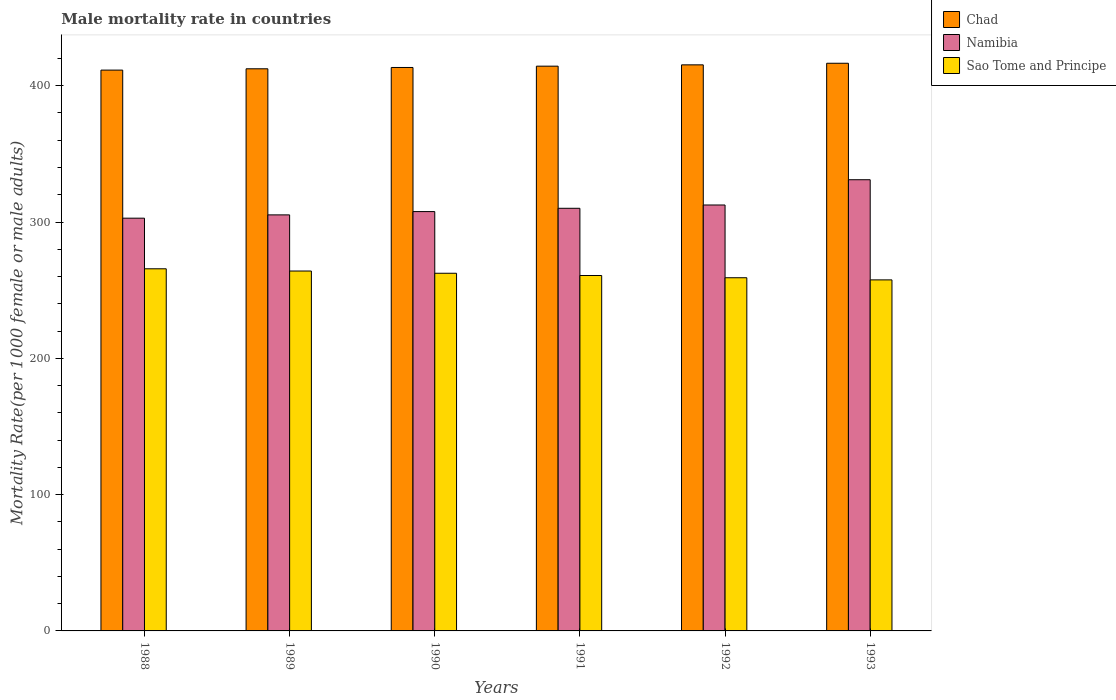How many groups of bars are there?
Your answer should be very brief. 6. Are the number of bars per tick equal to the number of legend labels?
Your response must be concise. Yes. Are the number of bars on each tick of the X-axis equal?
Offer a very short reply. Yes. How many bars are there on the 4th tick from the left?
Offer a terse response. 3. How many bars are there on the 3rd tick from the right?
Offer a very short reply. 3. What is the male mortality rate in Chad in 1993?
Your answer should be very brief. 416.46. Across all years, what is the maximum male mortality rate in Chad?
Provide a succinct answer. 416.46. Across all years, what is the minimum male mortality rate in Namibia?
Your answer should be compact. 302.8. In which year was the male mortality rate in Sao Tome and Principe maximum?
Provide a succinct answer. 1988. In which year was the male mortality rate in Sao Tome and Principe minimum?
Your response must be concise. 1993. What is the total male mortality rate in Namibia in the graph?
Your response must be concise. 1869.23. What is the difference between the male mortality rate in Chad in 1989 and that in 1991?
Give a very brief answer. -1.92. What is the difference between the male mortality rate in Chad in 1989 and the male mortality rate in Namibia in 1991?
Provide a succinct answer. 102.34. What is the average male mortality rate in Sao Tome and Principe per year?
Your answer should be compact. 261.58. In the year 1990, what is the difference between the male mortality rate in Chad and male mortality rate in Namibia?
Ensure brevity in your answer.  105.72. In how many years, is the male mortality rate in Namibia greater than 120?
Your response must be concise. 6. What is the ratio of the male mortality rate in Sao Tome and Principe in 1989 to that in 1990?
Provide a short and direct response. 1.01. What is the difference between the highest and the second highest male mortality rate in Chad?
Provide a short and direct response. 1.17. What is the difference between the highest and the lowest male mortality rate in Namibia?
Provide a short and direct response. 28.22. In how many years, is the male mortality rate in Namibia greater than the average male mortality rate in Namibia taken over all years?
Your response must be concise. 2. What does the 3rd bar from the left in 1988 represents?
Ensure brevity in your answer.  Sao Tome and Principe. What does the 1st bar from the right in 1993 represents?
Give a very brief answer. Sao Tome and Principe. How many bars are there?
Provide a succinct answer. 18. Are all the bars in the graph horizontal?
Ensure brevity in your answer.  No. What is the difference between two consecutive major ticks on the Y-axis?
Ensure brevity in your answer.  100. Are the values on the major ticks of Y-axis written in scientific E-notation?
Ensure brevity in your answer.  No. Where does the legend appear in the graph?
Provide a succinct answer. Top right. How are the legend labels stacked?
Make the answer very short. Vertical. What is the title of the graph?
Your response must be concise. Male mortality rate in countries. Does "Paraguay" appear as one of the legend labels in the graph?
Provide a succinct answer. No. What is the label or title of the Y-axis?
Give a very brief answer. Mortality Rate(per 1000 female or male adults). What is the Mortality Rate(per 1000 female or male adults) in Chad in 1988?
Ensure brevity in your answer.  411.44. What is the Mortality Rate(per 1000 female or male adults) of Namibia in 1988?
Offer a very short reply. 302.8. What is the Mortality Rate(per 1000 female or male adults) in Sao Tome and Principe in 1988?
Offer a terse response. 265.67. What is the Mortality Rate(per 1000 female or male adults) in Chad in 1989?
Provide a short and direct response. 412.4. What is the Mortality Rate(per 1000 female or male adults) of Namibia in 1989?
Your answer should be very brief. 305.22. What is the Mortality Rate(per 1000 female or male adults) in Sao Tome and Principe in 1989?
Give a very brief answer. 264.03. What is the Mortality Rate(per 1000 female or male adults) of Chad in 1990?
Provide a succinct answer. 413.36. What is the Mortality Rate(per 1000 female or male adults) in Namibia in 1990?
Your response must be concise. 307.64. What is the Mortality Rate(per 1000 female or male adults) of Sao Tome and Principe in 1990?
Offer a terse response. 262.39. What is the Mortality Rate(per 1000 female or male adults) in Chad in 1991?
Provide a short and direct response. 414.32. What is the Mortality Rate(per 1000 female or male adults) in Namibia in 1991?
Make the answer very short. 310.06. What is the Mortality Rate(per 1000 female or male adults) in Sao Tome and Principe in 1991?
Provide a succinct answer. 260.75. What is the Mortality Rate(per 1000 female or male adults) in Chad in 1992?
Provide a short and direct response. 415.29. What is the Mortality Rate(per 1000 female or male adults) in Namibia in 1992?
Your response must be concise. 312.48. What is the Mortality Rate(per 1000 female or male adults) of Sao Tome and Principe in 1992?
Provide a succinct answer. 259.11. What is the Mortality Rate(per 1000 female or male adults) of Chad in 1993?
Your answer should be compact. 416.46. What is the Mortality Rate(per 1000 female or male adults) in Namibia in 1993?
Make the answer very short. 331.02. What is the Mortality Rate(per 1000 female or male adults) in Sao Tome and Principe in 1993?
Provide a short and direct response. 257.53. Across all years, what is the maximum Mortality Rate(per 1000 female or male adults) of Chad?
Make the answer very short. 416.46. Across all years, what is the maximum Mortality Rate(per 1000 female or male adults) in Namibia?
Offer a terse response. 331.02. Across all years, what is the maximum Mortality Rate(per 1000 female or male adults) of Sao Tome and Principe?
Keep it short and to the point. 265.67. Across all years, what is the minimum Mortality Rate(per 1000 female or male adults) of Chad?
Provide a short and direct response. 411.44. Across all years, what is the minimum Mortality Rate(per 1000 female or male adults) of Namibia?
Provide a succinct answer. 302.8. Across all years, what is the minimum Mortality Rate(per 1000 female or male adults) of Sao Tome and Principe?
Give a very brief answer. 257.53. What is the total Mortality Rate(per 1000 female or male adults) of Chad in the graph?
Keep it short and to the point. 2483.27. What is the total Mortality Rate(per 1000 female or male adults) in Namibia in the graph?
Provide a succinct answer. 1869.23. What is the total Mortality Rate(per 1000 female or male adults) of Sao Tome and Principe in the graph?
Your answer should be compact. 1569.48. What is the difference between the Mortality Rate(per 1000 female or male adults) in Chad in 1988 and that in 1989?
Your response must be concise. -0.96. What is the difference between the Mortality Rate(per 1000 female or male adults) of Namibia in 1988 and that in 1989?
Provide a succinct answer. -2.42. What is the difference between the Mortality Rate(per 1000 female or male adults) of Sao Tome and Principe in 1988 and that in 1989?
Your answer should be compact. 1.64. What is the difference between the Mortality Rate(per 1000 female or male adults) in Chad in 1988 and that in 1990?
Make the answer very short. -1.92. What is the difference between the Mortality Rate(per 1000 female or male adults) of Namibia in 1988 and that in 1990?
Provide a succinct answer. -4.84. What is the difference between the Mortality Rate(per 1000 female or male adults) in Sao Tome and Principe in 1988 and that in 1990?
Offer a terse response. 3.28. What is the difference between the Mortality Rate(per 1000 female or male adults) of Chad in 1988 and that in 1991?
Make the answer very short. -2.88. What is the difference between the Mortality Rate(per 1000 female or male adults) of Namibia in 1988 and that in 1991?
Provide a succinct answer. -7.26. What is the difference between the Mortality Rate(per 1000 female or male adults) in Sao Tome and Principe in 1988 and that in 1991?
Ensure brevity in your answer.  4.92. What is the difference between the Mortality Rate(per 1000 female or male adults) of Chad in 1988 and that in 1992?
Offer a terse response. -3.85. What is the difference between the Mortality Rate(per 1000 female or male adults) of Namibia in 1988 and that in 1992?
Offer a very short reply. -9.68. What is the difference between the Mortality Rate(per 1000 female or male adults) of Sao Tome and Principe in 1988 and that in 1992?
Your response must be concise. 6.56. What is the difference between the Mortality Rate(per 1000 female or male adults) of Chad in 1988 and that in 1993?
Your answer should be compact. -5.02. What is the difference between the Mortality Rate(per 1000 female or male adults) in Namibia in 1988 and that in 1993?
Give a very brief answer. -28.22. What is the difference between the Mortality Rate(per 1000 female or male adults) in Sao Tome and Principe in 1988 and that in 1993?
Ensure brevity in your answer.  8.14. What is the difference between the Mortality Rate(per 1000 female or male adults) of Chad in 1989 and that in 1990?
Provide a short and direct response. -0.96. What is the difference between the Mortality Rate(per 1000 female or male adults) in Namibia in 1989 and that in 1990?
Make the answer very short. -2.42. What is the difference between the Mortality Rate(per 1000 female or male adults) in Sao Tome and Principe in 1989 and that in 1990?
Provide a succinct answer. 1.64. What is the difference between the Mortality Rate(per 1000 female or male adults) in Chad in 1989 and that in 1991?
Offer a very short reply. -1.92. What is the difference between the Mortality Rate(per 1000 female or male adults) of Namibia in 1989 and that in 1991?
Keep it short and to the point. -4.84. What is the difference between the Mortality Rate(per 1000 female or male adults) in Sao Tome and Principe in 1989 and that in 1991?
Your response must be concise. 3.28. What is the difference between the Mortality Rate(per 1000 female or male adults) in Chad in 1989 and that in 1992?
Provide a short and direct response. -2.88. What is the difference between the Mortality Rate(per 1000 female or male adults) of Namibia in 1989 and that in 1992?
Give a very brief answer. -7.26. What is the difference between the Mortality Rate(per 1000 female or male adults) in Sao Tome and Principe in 1989 and that in 1992?
Ensure brevity in your answer.  4.92. What is the difference between the Mortality Rate(per 1000 female or male adults) of Chad in 1989 and that in 1993?
Make the answer very short. -4.06. What is the difference between the Mortality Rate(per 1000 female or male adults) of Namibia in 1989 and that in 1993?
Offer a very short reply. -25.8. What is the difference between the Mortality Rate(per 1000 female or male adults) of Sao Tome and Principe in 1989 and that in 1993?
Your answer should be compact. 6.5. What is the difference between the Mortality Rate(per 1000 female or male adults) of Chad in 1990 and that in 1991?
Offer a terse response. -0.96. What is the difference between the Mortality Rate(per 1000 female or male adults) in Namibia in 1990 and that in 1991?
Offer a very short reply. -2.42. What is the difference between the Mortality Rate(per 1000 female or male adults) in Sao Tome and Principe in 1990 and that in 1991?
Ensure brevity in your answer.  1.64. What is the difference between the Mortality Rate(per 1000 female or male adults) in Chad in 1990 and that in 1992?
Make the answer very short. -1.92. What is the difference between the Mortality Rate(per 1000 female or male adults) of Namibia in 1990 and that in 1992?
Provide a short and direct response. -4.84. What is the difference between the Mortality Rate(per 1000 female or male adults) of Sao Tome and Principe in 1990 and that in 1992?
Your answer should be very brief. 3.28. What is the difference between the Mortality Rate(per 1000 female or male adults) of Chad in 1990 and that in 1993?
Offer a very short reply. -3.1. What is the difference between the Mortality Rate(per 1000 female or male adults) of Namibia in 1990 and that in 1993?
Ensure brevity in your answer.  -23.38. What is the difference between the Mortality Rate(per 1000 female or male adults) in Sao Tome and Principe in 1990 and that in 1993?
Your answer should be compact. 4.86. What is the difference between the Mortality Rate(per 1000 female or male adults) of Chad in 1991 and that in 1992?
Ensure brevity in your answer.  -0.96. What is the difference between the Mortality Rate(per 1000 female or male adults) of Namibia in 1991 and that in 1992?
Make the answer very short. -2.42. What is the difference between the Mortality Rate(per 1000 female or male adults) in Sao Tome and Principe in 1991 and that in 1992?
Offer a very short reply. 1.64. What is the difference between the Mortality Rate(per 1000 female or male adults) in Chad in 1991 and that in 1993?
Provide a succinct answer. -2.13. What is the difference between the Mortality Rate(per 1000 female or male adults) of Namibia in 1991 and that in 1993?
Your answer should be compact. -20.95. What is the difference between the Mortality Rate(per 1000 female or male adults) of Sao Tome and Principe in 1991 and that in 1993?
Your answer should be compact. 3.22. What is the difference between the Mortality Rate(per 1000 female or male adults) in Chad in 1992 and that in 1993?
Offer a terse response. -1.17. What is the difference between the Mortality Rate(per 1000 female or male adults) of Namibia in 1992 and that in 1993?
Keep it short and to the point. -18.54. What is the difference between the Mortality Rate(per 1000 female or male adults) of Sao Tome and Principe in 1992 and that in 1993?
Give a very brief answer. 1.58. What is the difference between the Mortality Rate(per 1000 female or male adults) of Chad in 1988 and the Mortality Rate(per 1000 female or male adults) of Namibia in 1989?
Offer a terse response. 106.22. What is the difference between the Mortality Rate(per 1000 female or male adults) in Chad in 1988 and the Mortality Rate(per 1000 female or male adults) in Sao Tome and Principe in 1989?
Offer a terse response. 147.41. What is the difference between the Mortality Rate(per 1000 female or male adults) of Namibia in 1988 and the Mortality Rate(per 1000 female or male adults) of Sao Tome and Principe in 1989?
Offer a terse response. 38.77. What is the difference between the Mortality Rate(per 1000 female or male adults) of Chad in 1988 and the Mortality Rate(per 1000 female or male adults) of Namibia in 1990?
Provide a short and direct response. 103.8. What is the difference between the Mortality Rate(per 1000 female or male adults) of Chad in 1988 and the Mortality Rate(per 1000 female or male adults) of Sao Tome and Principe in 1990?
Offer a very short reply. 149.05. What is the difference between the Mortality Rate(per 1000 female or male adults) of Namibia in 1988 and the Mortality Rate(per 1000 female or male adults) of Sao Tome and Principe in 1990?
Your answer should be very brief. 40.41. What is the difference between the Mortality Rate(per 1000 female or male adults) in Chad in 1988 and the Mortality Rate(per 1000 female or male adults) in Namibia in 1991?
Provide a succinct answer. 101.38. What is the difference between the Mortality Rate(per 1000 female or male adults) in Chad in 1988 and the Mortality Rate(per 1000 female or male adults) in Sao Tome and Principe in 1991?
Provide a short and direct response. 150.69. What is the difference between the Mortality Rate(per 1000 female or male adults) of Namibia in 1988 and the Mortality Rate(per 1000 female or male adults) of Sao Tome and Principe in 1991?
Offer a terse response. 42.05. What is the difference between the Mortality Rate(per 1000 female or male adults) of Chad in 1988 and the Mortality Rate(per 1000 female or male adults) of Namibia in 1992?
Offer a very short reply. 98.96. What is the difference between the Mortality Rate(per 1000 female or male adults) in Chad in 1988 and the Mortality Rate(per 1000 female or male adults) in Sao Tome and Principe in 1992?
Your answer should be compact. 152.33. What is the difference between the Mortality Rate(per 1000 female or male adults) of Namibia in 1988 and the Mortality Rate(per 1000 female or male adults) of Sao Tome and Principe in 1992?
Offer a terse response. 43.69. What is the difference between the Mortality Rate(per 1000 female or male adults) in Chad in 1988 and the Mortality Rate(per 1000 female or male adults) in Namibia in 1993?
Offer a terse response. 80.42. What is the difference between the Mortality Rate(per 1000 female or male adults) in Chad in 1988 and the Mortality Rate(per 1000 female or male adults) in Sao Tome and Principe in 1993?
Ensure brevity in your answer.  153.91. What is the difference between the Mortality Rate(per 1000 female or male adults) of Namibia in 1988 and the Mortality Rate(per 1000 female or male adults) of Sao Tome and Principe in 1993?
Offer a very short reply. 45.27. What is the difference between the Mortality Rate(per 1000 female or male adults) in Chad in 1989 and the Mortality Rate(per 1000 female or male adults) in Namibia in 1990?
Provide a succinct answer. 104.76. What is the difference between the Mortality Rate(per 1000 female or male adults) in Chad in 1989 and the Mortality Rate(per 1000 female or male adults) in Sao Tome and Principe in 1990?
Offer a terse response. 150.01. What is the difference between the Mortality Rate(per 1000 female or male adults) of Namibia in 1989 and the Mortality Rate(per 1000 female or male adults) of Sao Tome and Principe in 1990?
Your answer should be very brief. 42.83. What is the difference between the Mortality Rate(per 1000 female or male adults) in Chad in 1989 and the Mortality Rate(per 1000 female or male adults) in Namibia in 1991?
Keep it short and to the point. 102.34. What is the difference between the Mortality Rate(per 1000 female or male adults) in Chad in 1989 and the Mortality Rate(per 1000 female or male adults) in Sao Tome and Principe in 1991?
Ensure brevity in your answer.  151.65. What is the difference between the Mortality Rate(per 1000 female or male adults) of Namibia in 1989 and the Mortality Rate(per 1000 female or male adults) of Sao Tome and Principe in 1991?
Offer a terse response. 44.47. What is the difference between the Mortality Rate(per 1000 female or male adults) in Chad in 1989 and the Mortality Rate(per 1000 female or male adults) in Namibia in 1992?
Keep it short and to the point. 99.92. What is the difference between the Mortality Rate(per 1000 female or male adults) in Chad in 1989 and the Mortality Rate(per 1000 female or male adults) in Sao Tome and Principe in 1992?
Give a very brief answer. 153.29. What is the difference between the Mortality Rate(per 1000 female or male adults) in Namibia in 1989 and the Mortality Rate(per 1000 female or male adults) in Sao Tome and Principe in 1992?
Your answer should be compact. 46.11. What is the difference between the Mortality Rate(per 1000 female or male adults) in Chad in 1989 and the Mortality Rate(per 1000 female or male adults) in Namibia in 1993?
Ensure brevity in your answer.  81.38. What is the difference between the Mortality Rate(per 1000 female or male adults) of Chad in 1989 and the Mortality Rate(per 1000 female or male adults) of Sao Tome and Principe in 1993?
Give a very brief answer. 154.87. What is the difference between the Mortality Rate(per 1000 female or male adults) of Namibia in 1989 and the Mortality Rate(per 1000 female or male adults) of Sao Tome and Principe in 1993?
Offer a terse response. 47.69. What is the difference between the Mortality Rate(per 1000 female or male adults) in Chad in 1990 and the Mortality Rate(per 1000 female or male adults) in Namibia in 1991?
Your response must be concise. 103.3. What is the difference between the Mortality Rate(per 1000 female or male adults) of Chad in 1990 and the Mortality Rate(per 1000 female or male adults) of Sao Tome and Principe in 1991?
Your answer should be very brief. 152.61. What is the difference between the Mortality Rate(per 1000 female or male adults) in Namibia in 1990 and the Mortality Rate(per 1000 female or male adults) in Sao Tome and Principe in 1991?
Give a very brief answer. 46.89. What is the difference between the Mortality Rate(per 1000 female or male adults) in Chad in 1990 and the Mortality Rate(per 1000 female or male adults) in Namibia in 1992?
Make the answer very short. 100.88. What is the difference between the Mortality Rate(per 1000 female or male adults) in Chad in 1990 and the Mortality Rate(per 1000 female or male adults) in Sao Tome and Principe in 1992?
Your response must be concise. 154.25. What is the difference between the Mortality Rate(per 1000 female or male adults) of Namibia in 1990 and the Mortality Rate(per 1000 female or male adults) of Sao Tome and Principe in 1992?
Offer a terse response. 48.53. What is the difference between the Mortality Rate(per 1000 female or male adults) in Chad in 1990 and the Mortality Rate(per 1000 female or male adults) in Namibia in 1993?
Your answer should be very brief. 82.34. What is the difference between the Mortality Rate(per 1000 female or male adults) in Chad in 1990 and the Mortality Rate(per 1000 female or male adults) in Sao Tome and Principe in 1993?
Provide a succinct answer. 155.83. What is the difference between the Mortality Rate(per 1000 female or male adults) of Namibia in 1990 and the Mortality Rate(per 1000 female or male adults) of Sao Tome and Principe in 1993?
Your response must be concise. 50.11. What is the difference between the Mortality Rate(per 1000 female or male adults) of Chad in 1991 and the Mortality Rate(per 1000 female or male adults) of Namibia in 1992?
Your answer should be compact. 101.84. What is the difference between the Mortality Rate(per 1000 female or male adults) in Chad in 1991 and the Mortality Rate(per 1000 female or male adults) in Sao Tome and Principe in 1992?
Your answer should be compact. 155.21. What is the difference between the Mortality Rate(per 1000 female or male adults) in Namibia in 1991 and the Mortality Rate(per 1000 female or male adults) in Sao Tome and Principe in 1992?
Your answer should be compact. 50.95. What is the difference between the Mortality Rate(per 1000 female or male adults) in Chad in 1991 and the Mortality Rate(per 1000 female or male adults) in Namibia in 1993?
Make the answer very short. 83.31. What is the difference between the Mortality Rate(per 1000 female or male adults) of Chad in 1991 and the Mortality Rate(per 1000 female or male adults) of Sao Tome and Principe in 1993?
Provide a short and direct response. 156.79. What is the difference between the Mortality Rate(per 1000 female or male adults) in Namibia in 1991 and the Mortality Rate(per 1000 female or male adults) in Sao Tome and Principe in 1993?
Your response must be concise. 52.53. What is the difference between the Mortality Rate(per 1000 female or male adults) of Chad in 1992 and the Mortality Rate(per 1000 female or male adults) of Namibia in 1993?
Make the answer very short. 84.27. What is the difference between the Mortality Rate(per 1000 female or male adults) in Chad in 1992 and the Mortality Rate(per 1000 female or male adults) in Sao Tome and Principe in 1993?
Keep it short and to the point. 157.76. What is the difference between the Mortality Rate(per 1000 female or male adults) of Namibia in 1992 and the Mortality Rate(per 1000 female or male adults) of Sao Tome and Principe in 1993?
Your answer should be very brief. 54.95. What is the average Mortality Rate(per 1000 female or male adults) of Chad per year?
Your answer should be compact. 413.88. What is the average Mortality Rate(per 1000 female or male adults) in Namibia per year?
Your response must be concise. 311.54. What is the average Mortality Rate(per 1000 female or male adults) of Sao Tome and Principe per year?
Offer a terse response. 261.58. In the year 1988, what is the difference between the Mortality Rate(per 1000 female or male adults) in Chad and Mortality Rate(per 1000 female or male adults) in Namibia?
Provide a short and direct response. 108.64. In the year 1988, what is the difference between the Mortality Rate(per 1000 female or male adults) of Chad and Mortality Rate(per 1000 female or male adults) of Sao Tome and Principe?
Make the answer very short. 145.77. In the year 1988, what is the difference between the Mortality Rate(per 1000 female or male adults) of Namibia and Mortality Rate(per 1000 female or male adults) of Sao Tome and Principe?
Keep it short and to the point. 37.13. In the year 1989, what is the difference between the Mortality Rate(per 1000 female or male adults) in Chad and Mortality Rate(per 1000 female or male adults) in Namibia?
Provide a succinct answer. 107.18. In the year 1989, what is the difference between the Mortality Rate(per 1000 female or male adults) of Chad and Mortality Rate(per 1000 female or male adults) of Sao Tome and Principe?
Keep it short and to the point. 148.37. In the year 1989, what is the difference between the Mortality Rate(per 1000 female or male adults) in Namibia and Mortality Rate(per 1000 female or male adults) in Sao Tome and Principe?
Provide a short and direct response. 41.19. In the year 1990, what is the difference between the Mortality Rate(per 1000 female or male adults) in Chad and Mortality Rate(per 1000 female or male adults) in Namibia?
Keep it short and to the point. 105.72. In the year 1990, what is the difference between the Mortality Rate(per 1000 female or male adults) of Chad and Mortality Rate(per 1000 female or male adults) of Sao Tome and Principe?
Offer a very short reply. 150.97. In the year 1990, what is the difference between the Mortality Rate(per 1000 female or male adults) in Namibia and Mortality Rate(per 1000 female or male adults) in Sao Tome and Principe?
Offer a terse response. 45.25. In the year 1991, what is the difference between the Mortality Rate(per 1000 female or male adults) of Chad and Mortality Rate(per 1000 female or male adults) of Namibia?
Offer a terse response. 104.26. In the year 1991, what is the difference between the Mortality Rate(per 1000 female or male adults) in Chad and Mortality Rate(per 1000 female or male adults) in Sao Tome and Principe?
Provide a succinct answer. 153.57. In the year 1991, what is the difference between the Mortality Rate(per 1000 female or male adults) of Namibia and Mortality Rate(per 1000 female or male adults) of Sao Tome and Principe?
Offer a terse response. 49.31. In the year 1992, what is the difference between the Mortality Rate(per 1000 female or male adults) in Chad and Mortality Rate(per 1000 female or male adults) in Namibia?
Make the answer very short. 102.8. In the year 1992, what is the difference between the Mortality Rate(per 1000 female or male adults) of Chad and Mortality Rate(per 1000 female or male adults) of Sao Tome and Principe?
Offer a very short reply. 156.18. In the year 1992, what is the difference between the Mortality Rate(per 1000 female or male adults) in Namibia and Mortality Rate(per 1000 female or male adults) in Sao Tome and Principe?
Provide a short and direct response. 53.37. In the year 1993, what is the difference between the Mortality Rate(per 1000 female or male adults) of Chad and Mortality Rate(per 1000 female or male adults) of Namibia?
Your answer should be very brief. 85.44. In the year 1993, what is the difference between the Mortality Rate(per 1000 female or male adults) in Chad and Mortality Rate(per 1000 female or male adults) in Sao Tome and Principe?
Give a very brief answer. 158.93. In the year 1993, what is the difference between the Mortality Rate(per 1000 female or male adults) in Namibia and Mortality Rate(per 1000 female or male adults) in Sao Tome and Principe?
Give a very brief answer. 73.49. What is the ratio of the Mortality Rate(per 1000 female or male adults) of Namibia in 1988 to that in 1990?
Your answer should be compact. 0.98. What is the ratio of the Mortality Rate(per 1000 female or male adults) of Sao Tome and Principe in 1988 to that in 1990?
Offer a very short reply. 1.01. What is the ratio of the Mortality Rate(per 1000 female or male adults) in Namibia in 1988 to that in 1991?
Your answer should be very brief. 0.98. What is the ratio of the Mortality Rate(per 1000 female or male adults) of Sao Tome and Principe in 1988 to that in 1991?
Your response must be concise. 1.02. What is the ratio of the Mortality Rate(per 1000 female or male adults) in Chad in 1988 to that in 1992?
Offer a terse response. 0.99. What is the ratio of the Mortality Rate(per 1000 female or male adults) in Sao Tome and Principe in 1988 to that in 1992?
Your answer should be very brief. 1.03. What is the ratio of the Mortality Rate(per 1000 female or male adults) in Chad in 1988 to that in 1993?
Provide a short and direct response. 0.99. What is the ratio of the Mortality Rate(per 1000 female or male adults) of Namibia in 1988 to that in 1993?
Make the answer very short. 0.91. What is the ratio of the Mortality Rate(per 1000 female or male adults) of Sao Tome and Principe in 1988 to that in 1993?
Your response must be concise. 1.03. What is the ratio of the Mortality Rate(per 1000 female or male adults) of Chad in 1989 to that in 1990?
Your response must be concise. 1. What is the ratio of the Mortality Rate(per 1000 female or male adults) in Namibia in 1989 to that in 1990?
Your response must be concise. 0.99. What is the ratio of the Mortality Rate(per 1000 female or male adults) in Sao Tome and Principe in 1989 to that in 1990?
Your response must be concise. 1.01. What is the ratio of the Mortality Rate(per 1000 female or male adults) of Chad in 1989 to that in 1991?
Offer a very short reply. 1. What is the ratio of the Mortality Rate(per 1000 female or male adults) of Namibia in 1989 to that in 1991?
Provide a short and direct response. 0.98. What is the ratio of the Mortality Rate(per 1000 female or male adults) of Sao Tome and Principe in 1989 to that in 1991?
Ensure brevity in your answer.  1.01. What is the ratio of the Mortality Rate(per 1000 female or male adults) in Chad in 1989 to that in 1992?
Offer a terse response. 0.99. What is the ratio of the Mortality Rate(per 1000 female or male adults) of Namibia in 1989 to that in 1992?
Offer a very short reply. 0.98. What is the ratio of the Mortality Rate(per 1000 female or male adults) of Sao Tome and Principe in 1989 to that in 1992?
Provide a short and direct response. 1.02. What is the ratio of the Mortality Rate(per 1000 female or male adults) in Chad in 1989 to that in 1993?
Your answer should be very brief. 0.99. What is the ratio of the Mortality Rate(per 1000 female or male adults) of Namibia in 1989 to that in 1993?
Ensure brevity in your answer.  0.92. What is the ratio of the Mortality Rate(per 1000 female or male adults) of Sao Tome and Principe in 1989 to that in 1993?
Make the answer very short. 1.03. What is the ratio of the Mortality Rate(per 1000 female or male adults) of Chad in 1990 to that in 1992?
Provide a succinct answer. 1. What is the ratio of the Mortality Rate(per 1000 female or male adults) in Namibia in 1990 to that in 1992?
Give a very brief answer. 0.98. What is the ratio of the Mortality Rate(per 1000 female or male adults) in Sao Tome and Principe in 1990 to that in 1992?
Ensure brevity in your answer.  1.01. What is the ratio of the Mortality Rate(per 1000 female or male adults) of Namibia in 1990 to that in 1993?
Your response must be concise. 0.93. What is the ratio of the Mortality Rate(per 1000 female or male adults) in Sao Tome and Principe in 1990 to that in 1993?
Provide a short and direct response. 1.02. What is the ratio of the Mortality Rate(per 1000 female or male adults) of Namibia in 1991 to that in 1992?
Provide a succinct answer. 0.99. What is the ratio of the Mortality Rate(per 1000 female or male adults) of Sao Tome and Principe in 1991 to that in 1992?
Offer a very short reply. 1.01. What is the ratio of the Mortality Rate(per 1000 female or male adults) in Chad in 1991 to that in 1993?
Offer a terse response. 0.99. What is the ratio of the Mortality Rate(per 1000 female or male adults) in Namibia in 1991 to that in 1993?
Offer a terse response. 0.94. What is the ratio of the Mortality Rate(per 1000 female or male adults) of Sao Tome and Principe in 1991 to that in 1993?
Offer a very short reply. 1.01. What is the ratio of the Mortality Rate(per 1000 female or male adults) of Chad in 1992 to that in 1993?
Keep it short and to the point. 1. What is the ratio of the Mortality Rate(per 1000 female or male adults) in Namibia in 1992 to that in 1993?
Keep it short and to the point. 0.94. What is the ratio of the Mortality Rate(per 1000 female or male adults) of Sao Tome and Principe in 1992 to that in 1993?
Ensure brevity in your answer.  1.01. What is the difference between the highest and the second highest Mortality Rate(per 1000 female or male adults) in Chad?
Give a very brief answer. 1.17. What is the difference between the highest and the second highest Mortality Rate(per 1000 female or male adults) of Namibia?
Offer a very short reply. 18.54. What is the difference between the highest and the second highest Mortality Rate(per 1000 female or male adults) of Sao Tome and Principe?
Your answer should be very brief. 1.64. What is the difference between the highest and the lowest Mortality Rate(per 1000 female or male adults) in Chad?
Offer a terse response. 5.02. What is the difference between the highest and the lowest Mortality Rate(per 1000 female or male adults) of Namibia?
Your response must be concise. 28.22. What is the difference between the highest and the lowest Mortality Rate(per 1000 female or male adults) in Sao Tome and Principe?
Keep it short and to the point. 8.14. 